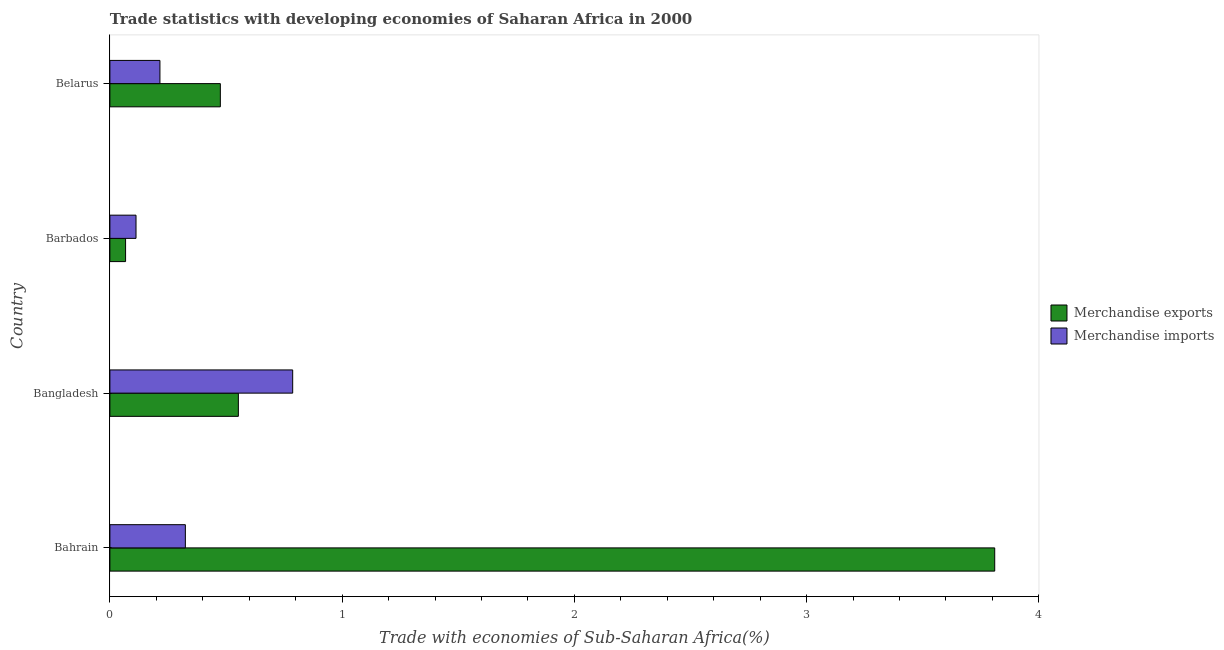How many groups of bars are there?
Your answer should be compact. 4. How many bars are there on the 2nd tick from the bottom?
Your response must be concise. 2. What is the label of the 4th group of bars from the top?
Your answer should be very brief. Bahrain. In how many cases, is the number of bars for a given country not equal to the number of legend labels?
Your response must be concise. 0. What is the merchandise imports in Bahrain?
Your answer should be compact. 0.32. Across all countries, what is the maximum merchandise imports?
Give a very brief answer. 0.79. Across all countries, what is the minimum merchandise exports?
Keep it short and to the point. 0.07. In which country was the merchandise imports minimum?
Your answer should be compact. Barbados. What is the total merchandise imports in the graph?
Your answer should be very brief. 1.44. What is the difference between the merchandise exports in Bangladesh and that in Barbados?
Provide a succinct answer. 0.49. What is the difference between the merchandise exports in Bangladesh and the merchandise imports in Belarus?
Offer a terse response. 0.34. What is the average merchandise imports per country?
Ensure brevity in your answer.  0.36. What is the difference between the merchandise imports and merchandise exports in Barbados?
Provide a succinct answer. 0.04. In how many countries, is the merchandise exports greater than 2.6 %?
Offer a very short reply. 1. What is the ratio of the merchandise exports in Bangladesh to that in Barbados?
Ensure brevity in your answer.  8.19. Is the difference between the merchandise exports in Bahrain and Barbados greater than the difference between the merchandise imports in Bahrain and Barbados?
Your answer should be compact. Yes. What is the difference between the highest and the second highest merchandise imports?
Provide a short and direct response. 0.46. What is the difference between the highest and the lowest merchandise imports?
Ensure brevity in your answer.  0.67. In how many countries, is the merchandise exports greater than the average merchandise exports taken over all countries?
Your answer should be compact. 1. What does the 1st bar from the top in Belarus represents?
Your answer should be very brief. Merchandise imports. What does the 1st bar from the bottom in Bangladesh represents?
Your answer should be compact. Merchandise exports. How many bars are there?
Ensure brevity in your answer.  8. Are all the bars in the graph horizontal?
Make the answer very short. Yes. What is the difference between two consecutive major ticks on the X-axis?
Ensure brevity in your answer.  1. Are the values on the major ticks of X-axis written in scientific E-notation?
Your answer should be compact. No. How many legend labels are there?
Provide a short and direct response. 2. What is the title of the graph?
Your answer should be compact. Trade statistics with developing economies of Saharan Africa in 2000. Does "Arms imports" appear as one of the legend labels in the graph?
Give a very brief answer. No. What is the label or title of the X-axis?
Provide a succinct answer. Trade with economies of Sub-Saharan Africa(%). What is the label or title of the Y-axis?
Provide a succinct answer. Country. What is the Trade with economies of Sub-Saharan Africa(%) in Merchandise exports in Bahrain?
Offer a terse response. 3.81. What is the Trade with economies of Sub-Saharan Africa(%) of Merchandise imports in Bahrain?
Make the answer very short. 0.32. What is the Trade with economies of Sub-Saharan Africa(%) in Merchandise exports in Bangladesh?
Make the answer very short. 0.55. What is the Trade with economies of Sub-Saharan Africa(%) of Merchandise imports in Bangladesh?
Provide a short and direct response. 0.79. What is the Trade with economies of Sub-Saharan Africa(%) in Merchandise exports in Barbados?
Offer a terse response. 0.07. What is the Trade with economies of Sub-Saharan Africa(%) of Merchandise imports in Barbados?
Offer a very short reply. 0.11. What is the Trade with economies of Sub-Saharan Africa(%) in Merchandise exports in Belarus?
Provide a succinct answer. 0.48. What is the Trade with economies of Sub-Saharan Africa(%) in Merchandise imports in Belarus?
Provide a succinct answer. 0.22. Across all countries, what is the maximum Trade with economies of Sub-Saharan Africa(%) of Merchandise exports?
Make the answer very short. 3.81. Across all countries, what is the maximum Trade with economies of Sub-Saharan Africa(%) of Merchandise imports?
Your response must be concise. 0.79. Across all countries, what is the minimum Trade with economies of Sub-Saharan Africa(%) of Merchandise exports?
Make the answer very short. 0.07. Across all countries, what is the minimum Trade with economies of Sub-Saharan Africa(%) of Merchandise imports?
Provide a short and direct response. 0.11. What is the total Trade with economies of Sub-Saharan Africa(%) of Merchandise exports in the graph?
Your answer should be compact. 4.91. What is the total Trade with economies of Sub-Saharan Africa(%) in Merchandise imports in the graph?
Your answer should be very brief. 1.44. What is the difference between the Trade with economies of Sub-Saharan Africa(%) of Merchandise exports in Bahrain and that in Bangladesh?
Your answer should be very brief. 3.26. What is the difference between the Trade with economies of Sub-Saharan Africa(%) of Merchandise imports in Bahrain and that in Bangladesh?
Your response must be concise. -0.46. What is the difference between the Trade with economies of Sub-Saharan Africa(%) in Merchandise exports in Bahrain and that in Barbados?
Give a very brief answer. 3.74. What is the difference between the Trade with economies of Sub-Saharan Africa(%) in Merchandise imports in Bahrain and that in Barbados?
Offer a terse response. 0.21. What is the difference between the Trade with economies of Sub-Saharan Africa(%) in Merchandise exports in Bahrain and that in Belarus?
Your answer should be compact. 3.33. What is the difference between the Trade with economies of Sub-Saharan Africa(%) in Merchandise imports in Bahrain and that in Belarus?
Give a very brief answer. 0.11. What is the difference between the Trade with economies of Sub-Saharan Africa(%) of Merchandise exports in Bangladesh and that in Barbados?
Keep it short and to the point. 0.49. What is the difference between the Trade with economies of Sub-Saharan Africa(%) in Merchandise imports in Bangladesh and that in Barbados?
Keep it short and to the point. 0.67. What is the difference between the Trade with economies of Sub-Saharan Africa(%) of Merchandise exports in Bangladesh and that in Belarus?
Provide a short and direct response. 0.08. What is the difference between the Trade with economies of Sub-Saharan Africa(%) of Merchandise imports in Bangladesh and that in Belarus?
Your answer should be very brief. 0.57. What is the difference between the Trade with economies of Sub-Saharan Africa(%) in Merchandise exports in Barbados and that in Belarus?
Make the answer very short. -0.41. What is the difference between the Trade with economies of Sub-Saharan Africa(%) of Merchandise imports in Barbados and that in Belarus?
Make the answer very short. -0.1. What is the difference between the Trade with economies of Sub-Saharan Africa(%) of Merchandise exports in Bahrain and the Trade with economies of Sub-Saharan Africa(%) of Merchandise imports in Bangladesh?
Your answer should be very brief. 3.02. What is the difference between the Trade with economies of Sub-Saharan Africa(%) in Merchandise exports in Bahrain and the Trade with economies of Sub-Saharan Africa(%) in Merchandise imports in Barbados?
Give a very brief answer. 3.7. What is the difference between the Trade with economies of Sub-Saharan Africa(%) in Merchandise exports in Bahrain and the Trade with economies of Sub-Saharan Africa(%) in Merchandise imports in Belarus?
Your answer should be very brief. 3.59. What is the difference between the Trade with economies of Sub-Saharan Africa(%) in Merchandise exports in Bangladesh and the Trade with economies of Sub-Saharan Africa(%) in Merchandise imports in Barbados?
Provide a succinct answer. 0.44. What is the difference between the Trade with economies of Sub-Saharan Africa(%) of Merchandise exports in Bangladesh and the Trade with economies of Sub-Saharan Africa(%) of Merchandise imports in Belarus?
Offer a very short reply. 0.34. What is the difference between the Trade with economies of Sub-Saharan Africa(%) in Merchandise exports in Barbados and the Trade with economies of Sub-Saharan Africa(%) in Merchandise imports in Belarus?
Offer a very short reply. -0.15. What is the average Trade with economies of Sub-Saharan Africa(%) in Merchandise exports per country?
Offer a terse response. 1.23. What is the average Trade with economies of Sub-Saharan Africa(%) of Merchandise imports per country?
Offer a terse response. 0.36. What is the difference between the Trade with economies of Sub-Saharan Africa(%) of Merchandise exports and Trade with economies of Sub-Saharan Africa(%) of Merchandise imports in Bahrain?
Keep it short and to the point. 3.48. What is the difference between the Trade with economies of Sub-Saharan Africa(%) in Merchandise exports and Trade with economies of Sub-Saharan Africa(%) in Merchandise imports in Bangladesh?
Ensure brevity in your answer.  -0.23. What is the difference between the Trade with economies of Sub-Saharan Africa(%) of Merchandise exports and Trade with economies of Sub-Saharan Africa(%) of Merchandise imports in Barbados?
Offer a terse response. -0.04. What is the difference between the Trade with economies of Sub-Saharan Africa(%) of Merchandise exports and Trade with economies of Sub-Saharan Africa(%) of Merchandise imports in Belarus?
Ensure brevity in your answer.  0.26. What is the ratio of the Trade with economies of Sub-Saharan Africa(%) in Merchandise exports in Bahrain to that in Bangladesh?
Offer a very short reply. 6.89. What is the ratio of the Trade with economies of Sub-Saharan Africa(%) in Merchandise imports in Bahrain to that in Bangladesh?
Ensure brevity in your answer.  0.41. What is the ratio of the Trade with economies of Sub-Saharan Africa(%) in Merchandise exports in Bahrain to that in Barbados?
Offer a very short reply. 56.41. What is the ratio of the Trade with economies of Sub-Saharan Africa(%) in Merchandise imports in Bahrain to that in Barbados?
Provide a short and direct response. 2.89. What is the ratio of the Trade with economies of Sub-Saharan Africa(%) of Merchandise exports in Bahrain to that in Belarus?
Make the answer very short. 8.01. What is the ratio of the Trade with economies of Sub-Saharan Africa(%) of Merchandise imports in Bahrain to that in Belarus?
Your answer should be compact. 1.51. What is the ratio of the Trade with economies of Sub-Saharan Africa(%) of Merchandise exports in Bangladesh to that in Barbados?
Your response must be concise. 8.19. What is the ratio of the Trade with economies of Sub-Saharan Africa(%) of Merchandise imports in Bangladesh to that in Barbados?
Offer a terse response. 6.99. What is the ratio of the Trade with economies of Sub-Saharan Africa(%) in Merchandise exports in Bangladesh to that in Belarus?
Provide a short and direct response. 1.16. What is the ratio of the Trade with economies of Sub-Saharan Africa(%) of Merchandise imports in Bangladesh to that in Belarus?
Offer a terse response. 3.65. What is the ratio of the Trade with economies of Sub-Saharan Africa(%) of Merchandise exports in Barbados to that in Belarus?
Your answer should be compact. 0.14. What is the ratio of the Trade with economies of Sub-Saharan Africa(%) of Merchandise imports in Barbados to that in Belarus?
Offer a terse response. 0.52. What is the difference between the highest and the second highest Trade with economies of Sub-Saharan Africa(%) of Merchandise exports?
Your answer should be very brief. 3.26. What is the difference between the highest and the second highest Trade with economies of Sub-Saharan Africa(%) of Merchandise imports?
Give a very brief answer. 0.46. What is the difference between the highest and the lowest Trade with economies of Sub-Saharan Africa(%) in Merchandise exports?
Provide a short and direct response. 3.74. What is the difference between the highest and the lowest Trade with economies of Sub-Saharan Africa(%) in Merchandise imports?
Keep it short and to the point. 0.67. 